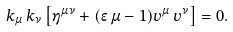Convert formula to latex. <formula><loc_0><loc_0><loc_500><loc_500>k _ { \mu } \, k _ { \nu } \left [ \eta ^ { \mu \nu } + ( \epsilon \, \mu - 1 ) v ^ { \mu } \, v ^ { \nu } \right ] = 0 .</formula> 